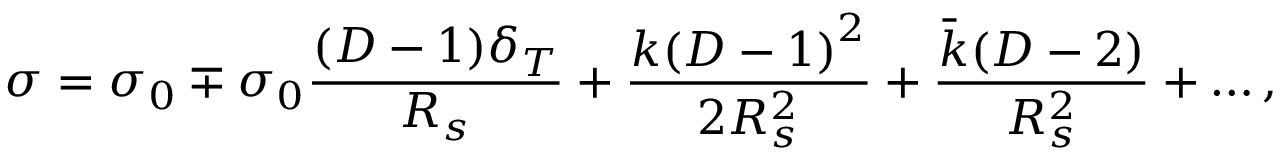<formula> <loc_0><loc_0><loc_500><loc_500>\sigma = \sigma _ { 0 } \mp \sigma _ { 0 } \frac { ( D - 1 ) \delta _ { T } } { R _ { s } } + \frac { k { ( D - 1 ) } ^ { 2 } } { 2 R _ { s } ^ { 2 } } + \frac { \bar { k } ( D - 2 ) } { R _ { s } ^ { 2 } } + \dots ,</formula> 